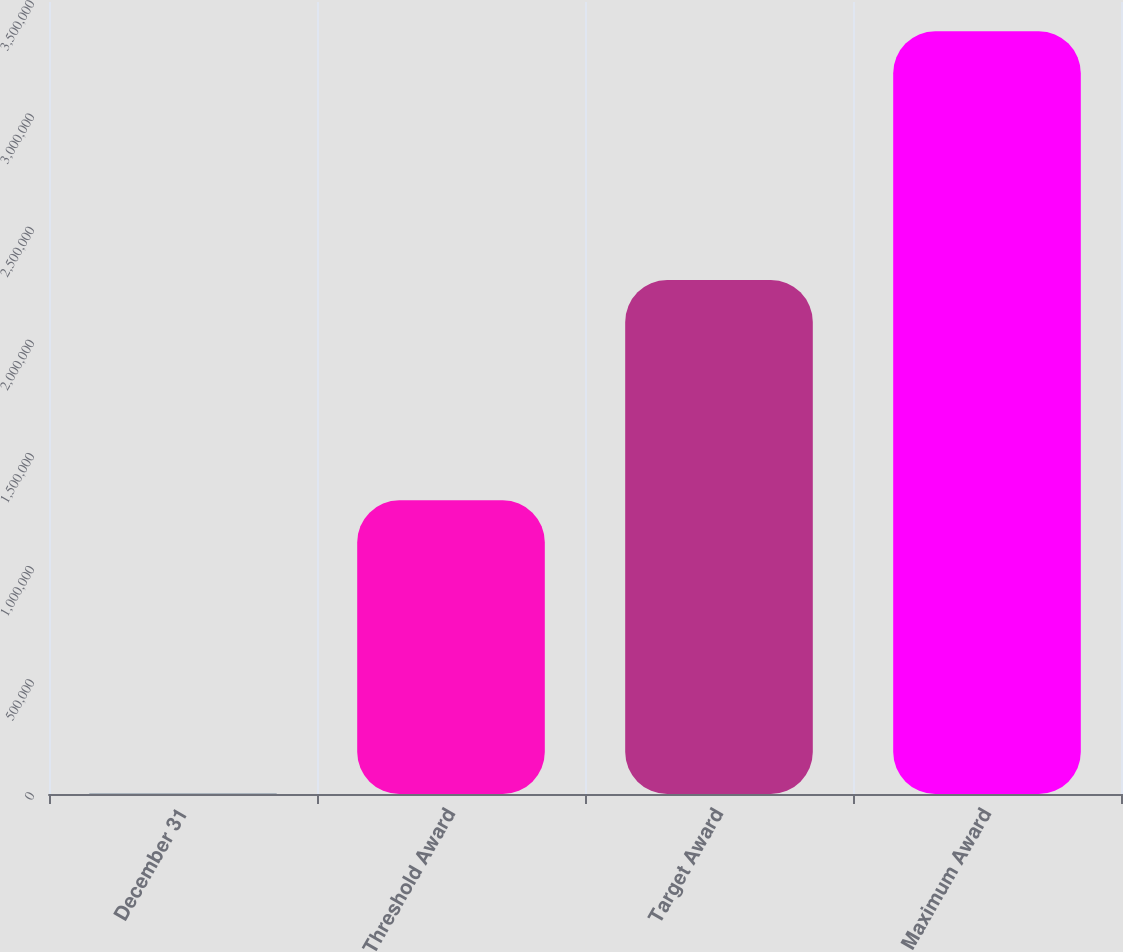<chart> <loc_0><loc_0><loc_500><loc_500><bar_chart><fcel>December 31<fcel>Threshold Award<fcel>Target Award<fcel>Maximum Award<nl><fcel>2006<fcel>1.29763e+06<fcel>2.27124e+06<fcel>3.37086e+06<nl></chart> 